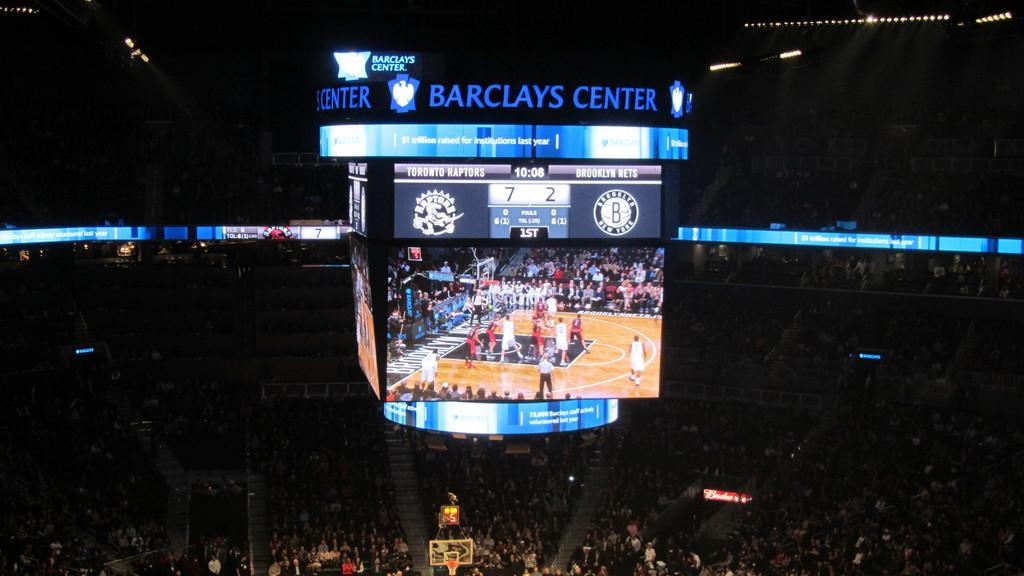Provide a one-sentence caption for the provided image. A basketball game at the Barclays Center is crowded with people. 